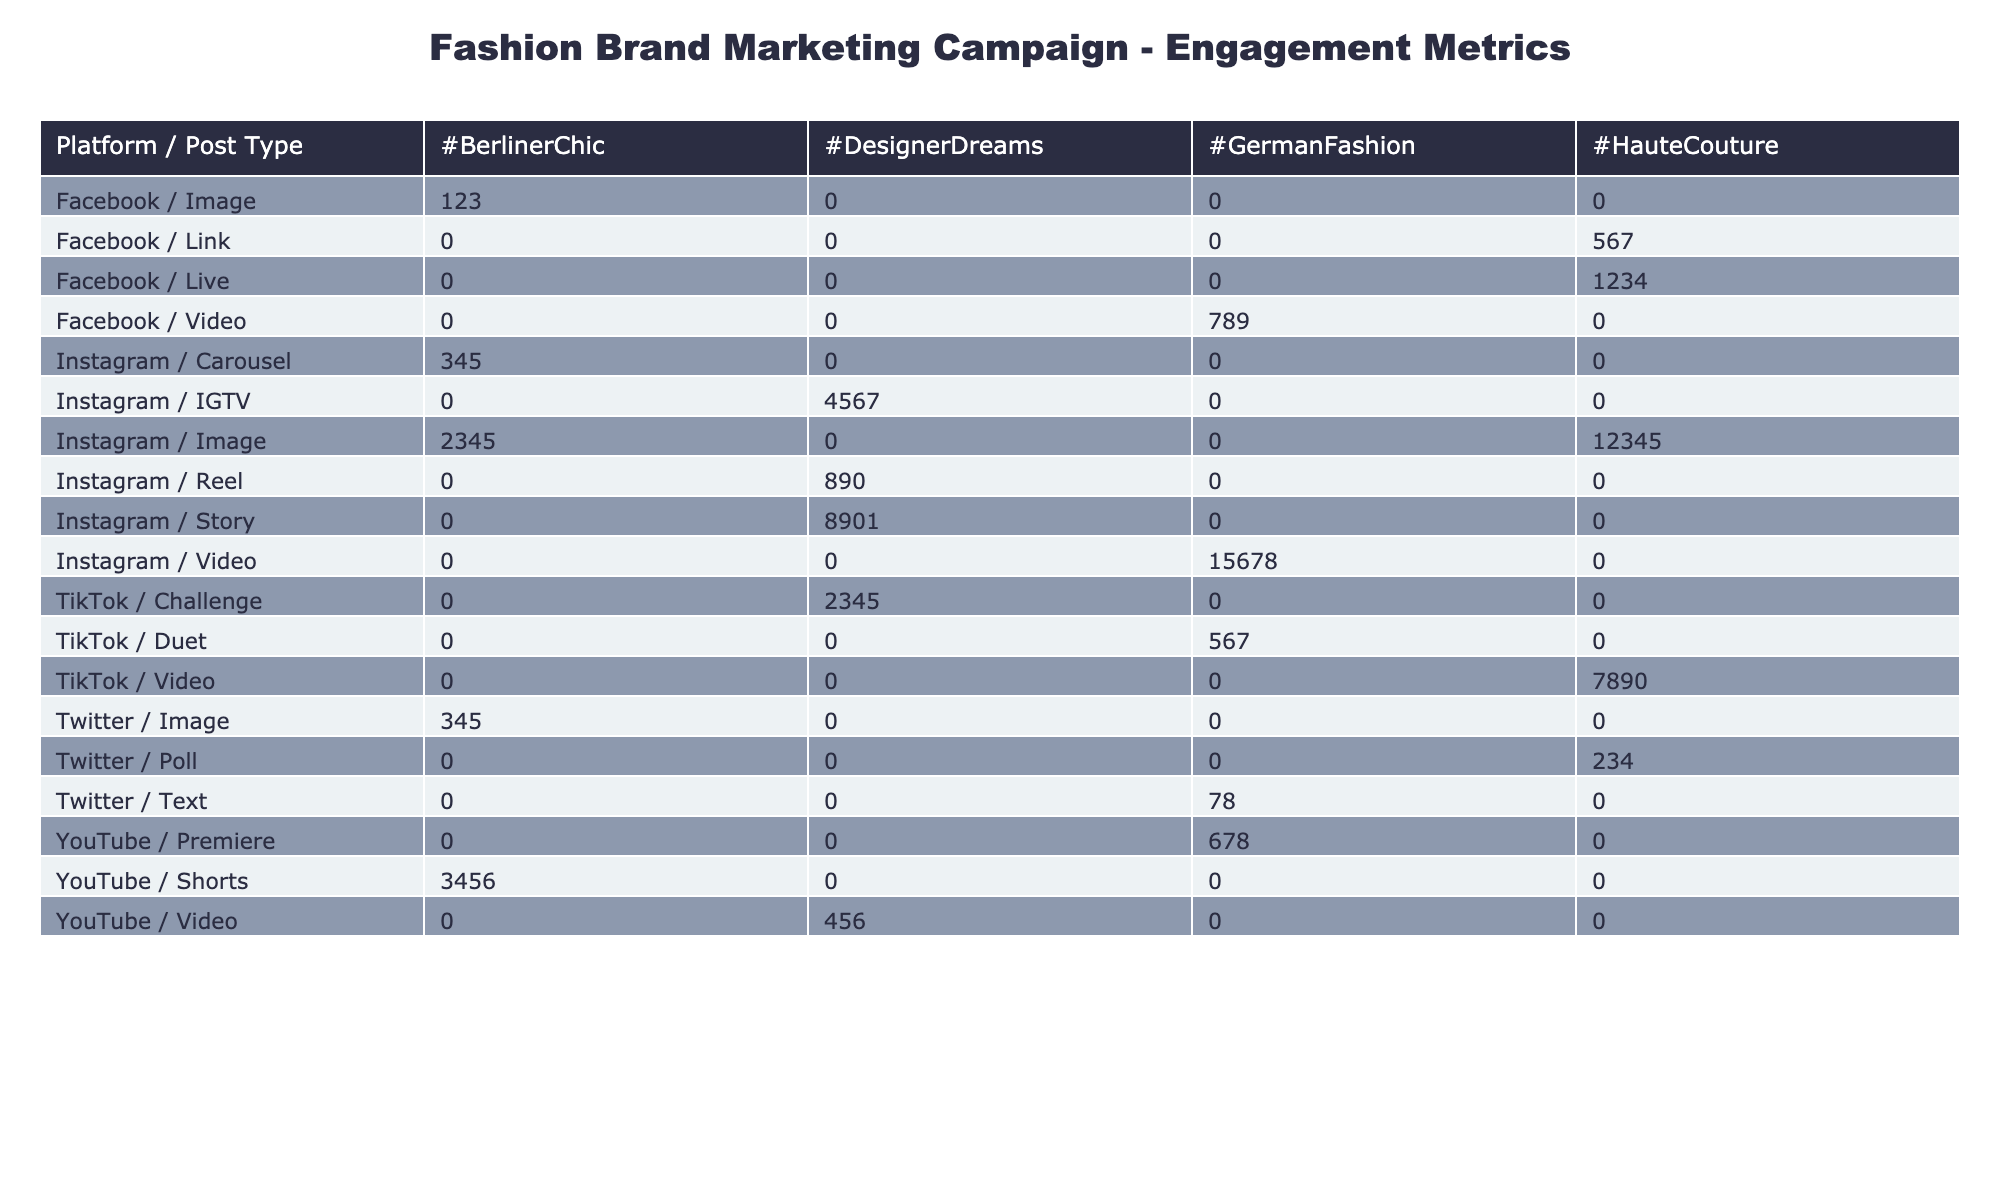What is the highest engagement count for Instagram posts? The highest engagement count can be identified by looking for the maximum value in the 'Engagement Count' column for Instagram. The values for Instagram are 2345, 15678, 8901, 345, 4567, and 12345. The maximum value is 15678, corresponding to the Video post on May 2, 2023.
Answer: 15678 Which post type on Facebook generated the most engagement overall? To determine the post type with the most engagement on Facebook, we need to sum the engagement counts for each post type. The totals are: Link (567), Image (123), Video (789), and Live (1234). Adding these gives the totals: 567 + 123 + 789 + 1234 = 2713 for Facebook. The Live post type has the highest engagement count of 1234, higher than the other types.
Answer: Live Did the TikTok platform have any influencer collaborations? By checking the 'Influencer Collaboration' column for TikTok, we see the rows for TikTok: Video (7890) with None, Duet (567) with None, and Challenge (2345) with None. There are no entries with an influencer collaboration.
Answer: No What is the total engagement count for 'Likes' across all platforms? To calculate the total engagement count for 'Likes,' we filter the data to include only those rows with the engagement type 'Likes.' The values are 2345 (Instagram), 78 (Twitter), and 345 (Twitter on image). Summing these gives us 2345 + 78 + 345 = 2768.
Answer: 2768 Which platform had the highest average engagement count across all post types? First, we will calculate the total engagement count for each platform: Instagram (2345 + 15678 + 8901 + 345 + 4567 + 12345 = 23431), Facebook (567 + 123 + 789 + 1234 = 2713), Twitter (78 + 234 + 345 = 657), YouTube (456 + 678 = 1134), and TikTok (7890 + 567 + 2345 = 10702). The average is calculated by dividing by the number of post types for each platform. Instagram has 6 posts, Facebook has 4 posts, Twitter has 3 posts, YouTube has 2 posts, and TikTok has 3 posts. The averages are as follows: Instagram (23431/6 = 3905.17), Facebook (2713/4 = 678.25), Twitter (657/3 = 219), YouTube (1134/2 = 567), and TikTok (10702/3 = 3567.33). The highest average is from Instagram at 3905.17.
Answer: Instagram 